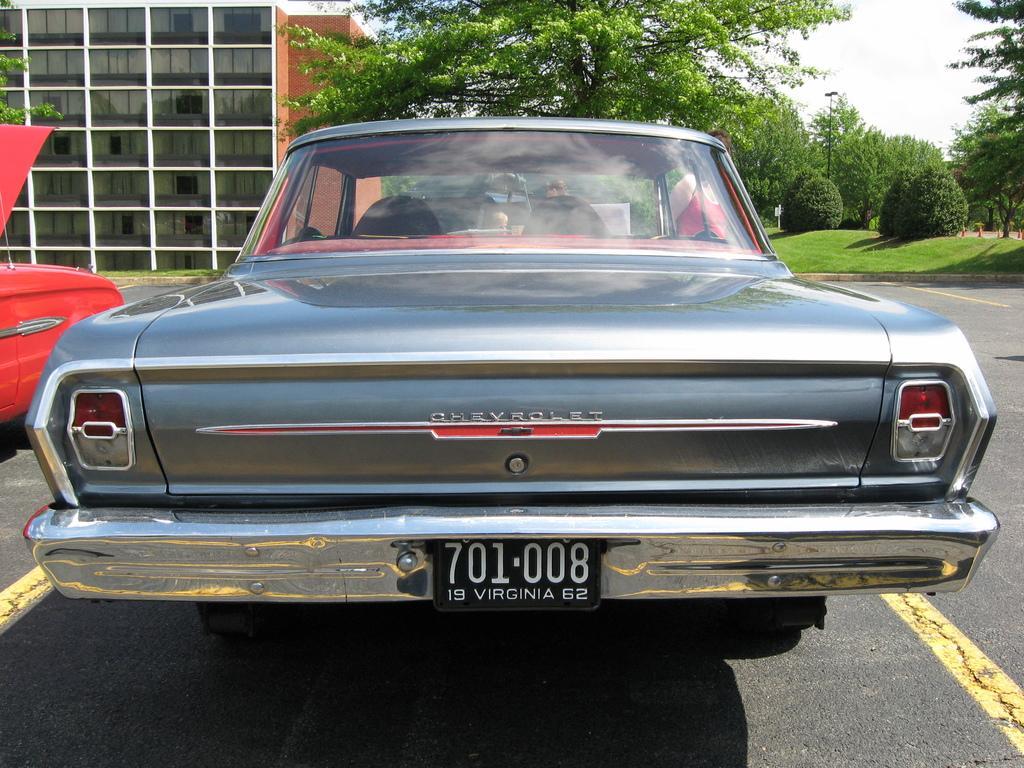Describe this image in one or two sentences. There are vehicles on the road. In the background we can see a building, trees, plants, grass, pole, and sky. 